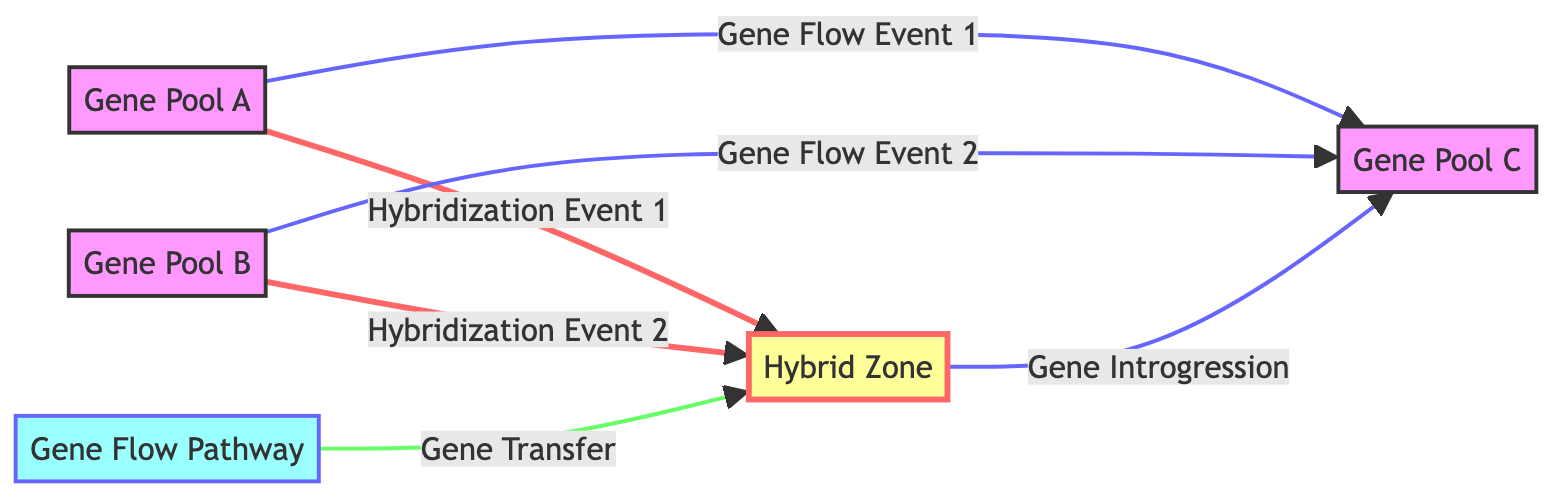What are the two gene pools that hybridize to form the Hybrid Zone? The diagram shows that Gene Pool A and Gene Pool B both connect to the Hybrid Zone through hybridization events, indicating that these two gene pools are involved in hybridization to create the hybrid population.
Answer: Gene Pool A and Gene Pool B How many hybridization events are depicted in the diagram? The diagram indicates two directed edges labeled as hybridization events connecting the respective gene pools to the Hybrid Zone. Therefore, counting these edges shows that there are two hybridization events.
Answer: 2 Which gene flow pathway is shown in the diagram? The diagram specifies a directed edge labeled "Gene Flow Pathway" leading into the Hybrid Zone, outlining that this pathway enables gene flow from external sources into the hybrid population.
Answer: Gene Flow Pathway What is the result of the gene flow event from Gene Pool A? In the diagram, Gene Flow Event 1 from Gene Pool A leads to Gene Pool C, indicating that the flow of genes from Gene Pool A results in contributions to Gene Pool C.
Answer: Gene Pool C What happens to the genes in the Hybrid Zone according to the diagram? The diagram indicates that there is a directed edge representing gene introgression from the Hybrid Zone to Gene Pool C, suggesting that genes from the Hybrid Zone are integrated into Gene Pool C, altering its genetic makeup.
Answer: Gene Introgression Which two gene pools contribute to Gene Flow Event 2? The diagram illustrates that Gene Flow Event 2 occurs from Gene Pool B to Gene Pool C, showing that Gene Pool B is participating in this particular gene flow event. Therefore, the answer is based on the nodes connected by this event.
Answer: Gene Pool B and Gene Pool C How many total nodes are present in the diagram? The diagram lists five distinct nodes: Gene Pool A, Gene Pool B, Hybrid Zone, Gene Pool C, and Gene Flow Pathway. Counting these points provides the total number of nodes represented in the diagram.
Answer: 5 Which event connects the Gene Flow Pathway to the Hybrid Zone? The diagram illustrates a directed edge labeled "Gene Transfer" that connects the Gene Flow Pathway to the Hybrid Zone, indicating that this is the specific event that facilitates gene transfer into the hybrid population.
Answer: Gene Transfer What is the outcome of the Hybridization Event 1? The directed edge labeled "Hybridization Event 1" connects Gene Pool A to the Hybrid Zone, suggesting that this event leads to the introduction of genes from Gene Pool A into the Hybrid Zone, resulting in hybrid organisms.
Answer: Hybridized Genes in Hybrid Zone 